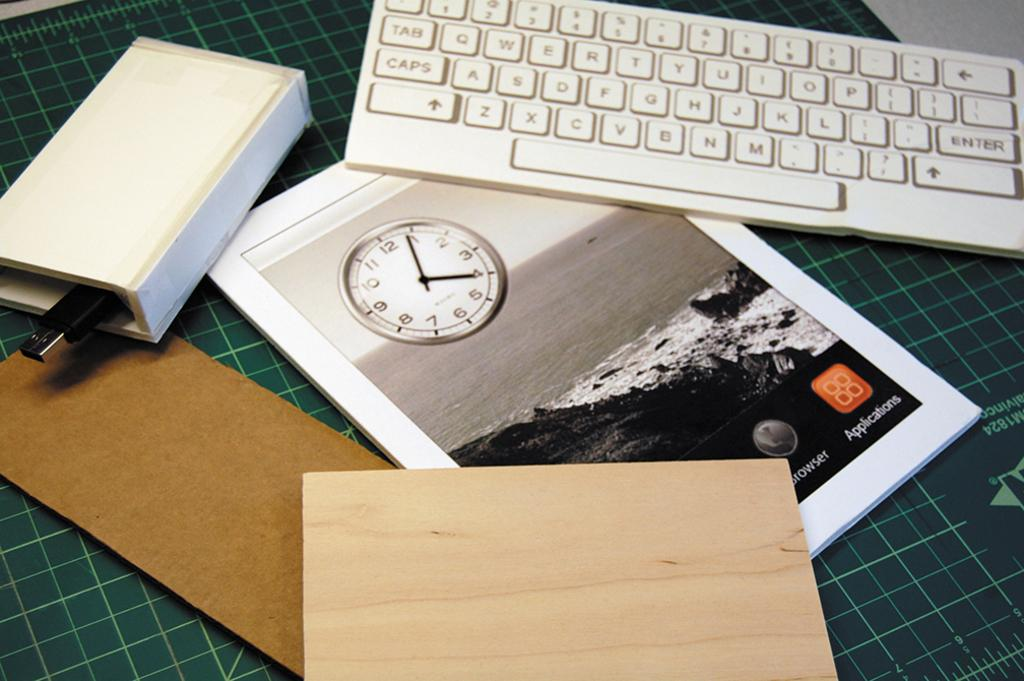<image>
Describe the image concisely. A green mat has a variety of things on it, including a computer keyboard and a booklet that has a clock on it that shows a time of 4:04. 